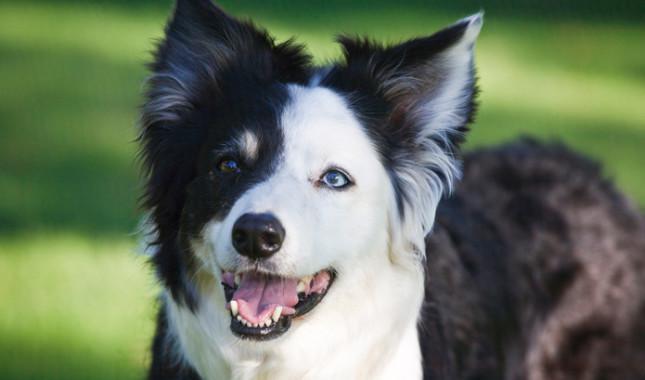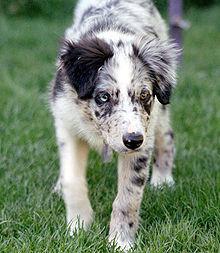The first image is the image on the left, the second image is the image on the right. Given the left and right images, does the statement "In one image, a dog is shown with sheep." hold true? Answer yes or no. No. The first image is the image on the left, the second image is the image on the right. Assess this claim about the two images: "There are two dogs". Correct or not? Answer yes or no. Yes. 